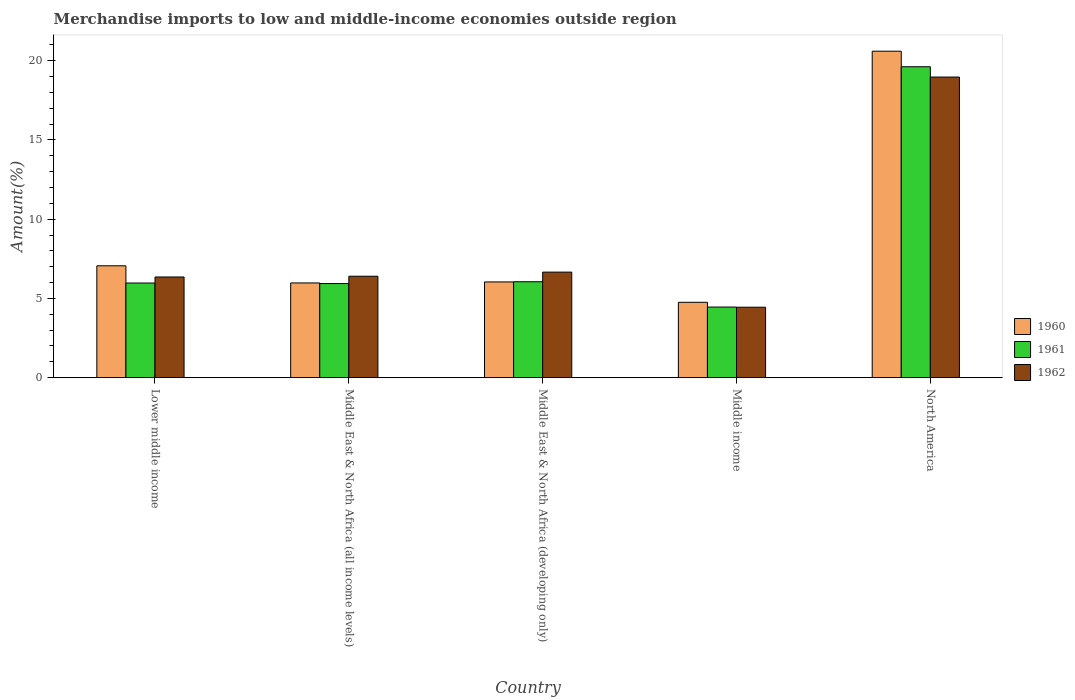How many groups of bars are there?
Your answer should be very brief. 5. Are the number of bars per tick equal to the number of legend labels?
Ensure brevity in your answer.  Yes. Are the number of bars on each tick of the X-axis equal?
Offer a very short reply. Yes. What is the percentage of amount earned from merchandise imports in 1961 in Lower middle income?
Your answer should be compact. 5.97. Across all countries, what is the maximum percentage of amount earned from merchandise imports in 1960?
Offer a terse response. 20.6. Across all countries, what is the minimum percentage of amount earned from merchandise imports in 1962?
Keep it short and to the point. 4.44. In which country was the percentage of amount earned from merchandise imports in 1961 maximum?
Provide a succinct answer. North America. In which country was the percentage of amount earned from merchandise imports in 1961 minimum?
Offer a terse response. Middle income. What is the total percentage of amount earned from merchandise imports in 1960 in the graph?
Give a very brief answer. 44.43. What is the difference between the percentage of amount earned from merchandise imports in 1962 in Middle East & North Africa (all income levels) and that in Middle East & North Africa (developing only)?
Make the answer very short. -0.26. What is the difference between the percentage of amount earned from merchandise imports in 1961 in Middle East & North Africa (all income levels) and the percentage of amount earned from merchandise imports in 1962 in Middle income?
Provide a short and direct response. 1.49. What is the average percentage of amount earned from merchandise imports in 1962 per country?
Your answer should be compact. 8.56. What is the difference between the percentage of amount earned from merchandise imports of/in 1961 and percentage of amount earned from merchandise imports of/in 1962 in Middle East & North Africa (developing only)?
Give a very brief answer. -0.61. What is the ratio of the percentage of amount earned from merchandise imports in 1962 in Middle income to that in North America?
Provide a short and direct response. 0.23. Is the percentage of amount earned from merchandise imports in 1962 in Lower middle income less than that in Middle income?
Ensure brevity in your answer.  No. Is the difference between the percentage of amount earned from merchandise imports in 1961 in Middle East & North Africa (developing only) and Middle income greater than the difference between the percentage of amount earned from merchandise imports in 1962 in Middle East & North Africa (developing only) and Middle income?
Keep it short and to the point. No. What is the difference between the highest and the second highest percentage of amount earned from merchandise imports in 1962?
Provide a short and direct response. 12.31. What is the difference between the highest and the lowest percentage of amount earned from merchandise imports in 1961?
Provide a short and direct response. 15.16. In how many countries, is the percentage of amount earned from merchandise imports in 1962 greater than the average percentage of amount earned from merchandise imports in 1962 taken over all countries?
Offer a very short reply. 1. How many bars are there?
Your answer should be very brief. 15. How many countries are there in the graph?
Provide a succinct answer. 5. Does the graph contain grids?
Ensure brevity in your answer.  No. How many legend labels are there?
Your answer should be very brief. 3. How are the legend labels stacked?
Ensure brevity in your answer.  Vertical. What is the title of the graph?
Offer a terse response. Merchandise imports to low and middle-income economies outside region. Does "2011" appear as one of the legend labels in the graph?
Your response must be concise. No. What is the label or title of the X-axis?
Your answer should be very brief. Country. What is the label or title of the Y-axis?
Keep it short and to the point. Amount(%). What is the Amount(%) in 1960 in Lower middle income?
Provide a short and direct response. 7.06. What is the Amount(%) in 1961 in Lower middle income?
Keep it short and to the point. 5.97. What is the Amount(%) of 1962 in Lower middle income?
Ensure brevity in your answer.  6.35. What is the Amount(%) of 1960 in Middle East & North Africa (all income levels)?
Your response must be concise. 5.98. What is the Amount(%) in 1961 in Middle East & North Africa (all income levels)?
Provide a short and direct response. 5.94. What is the Amount(%) in 1962 in Middle East & North Africa (all income levels)?
Provide a short and direct response. 6.4. What is the Amount(%) of 1960 in Middle East & North Africa (developing only)?
Keep it short and to the point. 6.04. What is the Amount(%) in 1961 in Middle East & North Africa (developing only)?
Your answer should be very brief. 6.05. What is the Amount(%) in 1962 in Middle East & North Africa (developing only)?
Your response must be concise. 6.66. What is the Amount(%) in 1960 in Middle income?
Provide a short and direct response. 4.75. What is the Amount(%) of 1961 in Middle income?
Offer a terse response. 4.45. What is the Amount(%) in 1962 in Middle income?
Provide a short and direct response. 4.44. What is the Amount(%) in 1960 in North America?
Provide a succinct answer. 20.6. What is the Amount(%) in 1961 in North America?
Your answer should be very brief. 19.62. What is the Amount(%) in 1962 in North America?
Provide a short and direct response. 18.97. Across all countries, what is the maximum Amount(%) of 1960?
Keep it short and to the point. 20.6. Across all countries, what is the maximum Amount(%) in 1961?
Your answer should be compact. 19.62. Across all countries, what is the maximum Amount(%) of 1962?
Ensure brevity in your answer.  18.97. Across all countries, what is the minimum Amount(%) of 1960?
Offer a very short reply. 4.75. Across all countries, what is the minimum Amount(%) in 1961?
Your answer should be very brief. 4.45. Across all countries, what is the minimum Amount(%) of 1962?
Provide a short and direct response. 4.44. What is the total Amount(%) in 1960 in the graph?
Provide a short and direct response. 44.43. What is the total Amount(%) in 1961 in the graph?
Give a very brief answer. 42.03. What is the total Amount(%) of 1962 in the graph?
Provide a succinct answer. 42.82. What is the difference between the Amount(%) in 1960 in Lower middle income and that in Middle East & North Africa (all income levels)?
Your answer should be compact. 1.08. What is the difference between the Amount(%) of 1961 in Lower middle income and that in Middle East & North Africa (all income levels)?
Ensure brevity in your answer.  0.03. What is the difference between the Amount(%) of 1962 in Lower middle income and that in Middle East & North Africa (all income levels)?
Give a very brief answer. -0.05. What is the difference between the Amount(%) of 1960 in Lower middle income and that in Middle East & North Africa (developing only)?
Your answer should be compact. 1.02. What is the difference between the Amount(%) in 1961 in Lower middle income and that in Middle East & North Africa (developing only)?
Provide a succinct answer. -0.08. What is the difference between the Amount(%) of 1962 in Lower middle income and that in Middle East & North Africa (developing only)?
Your answer should be compact. -0.31. What is the difference between the Amount(%) in 1960 in Lower middle income and that in Middle income?
Your response must be concise. 2.3. What is the difference between the Amount(%) of 1961 in Lower middle income and that in Middle income?
Offer a very short reply. 1.52. What is the difference between the Amount(%) in 1962 in Lower middle income and that in Middle income?
Ensure brevity in your answer.  1.91. What is the difference between the Amount(%) of 1960 in Lower middle income and that in North America?
Keep it short and to the point. -13.54. What is the difference between the Amount(%) of 1961 in Lower middle income and that in North America?
Keep it short and to the point. -13.64. What is the difference between the Amount(%) of 1962 in Lower middle income and that in North America?
Your answer should be compact. -12.61. What is the difference between the Amount(%) in 1960 in Middle East & North Africa (all income levels) and that in Middle East & North Africa (developing only)?
Your response must be concise. -0.06. What is the difference between the Amount(%) in 1961 in Middle East & North Africa (all income levels) and that in Middle East & North Africa (developing only)?
Offer a terse response. -0.11. What is the difference between the Amount(%) in 1962 in Middle East & North Africa (all income levels) and that in Middle East & North Africa (developing only)?
Offer a very short reply. -0.26. What is the difference between the Amount(%) in 1960 in Middle East & North Africa (all income levels) and that in Middle income?
Keep it short and to the point. 1.22. What is the difference between the Amount(%) of 1961 in Middle East & North Africa (all income levels) and that in Middle income?
Provide a succinct answer. 1.48. What is the difference between the Amount(%) of 1962 in Middle East & North Africa (all income levels) and that in Middle income?
Ensure brevity in your answer.  1.95. What is the difference between the Amount(%) in 1960 in Middle East & North Africa (all income levels) and that in North America?
Make the answer very short. -14.62. What is the difference between the Amount(%) in 1961 in Middle East & North Africa (all income levels) and that in North America?
Offer a very short reply. -13.68. What is the difference between the Amount(%) in 1962 in Middle East & North Africa (all income levels) and that in North America?
Your response must be concise. -12.57. What is the difference between the Amount(%) of 1960 in Middle East & North Africa (developing only) and that in Middle income?
Offer a very short reply. 1.29. What is the difference between the Amount(%) of 1961 in Middle East & North Africa (developing only) and that in Middle income?
Make the answer very short. 1.6. What is the difference between the Amount(%) of 1962 in Middle East & North Africa (developing only) and that in Middle income?
Provide a short and direct response. 2.21. What is the difference between the Amount(%) of 1960 in Middle East & North Africa (developing only) and that in North America?
Make the answer very short. -14.56. What is the difference between the Amount(%) of 1961 in Middle East & North Africa (developing only) and that in North America?
Your answer should be very brief. -13.56. What is the difference between the Amount(%) of 1962 in Middle East & North Africa (developing only) and that in North America?
Ensure brevity in your answer.  -12.31. What is the difference between the Amount(%) of 1960 in Middle income and that in North America?
Your answer should be compact. -15.84. What is the difference between the Amount(%) of 1961 in Middle income and that in North America?
Your answer should be very brief. -15.16. What is the difference between the Amount(%) in 1962 in Middle income and that in North America?
Your response must be concise. -14.52. What is the difference between the Amount(%) in 1960 in Lower middle income and the Amount(%) in 1961 in Middle East & North Africa (all income levels)?
Ensure brevity in your answer.  1.12. What is the difference between the Amount(%) of 1960 in Lower middle income and the Amount(%) of 1962 in Middle East & North Africa (all income levels)?
Make the answer very short. 0.66. What is the difference between the Amount(%) of 1961 in Lower middle income and the Amount(%) of 1962 in Middle East & North Africa (all income levels)?
Your answer should be compact. -0.43. What is the difference between the Amount(%) of 1960 in Lower middle income and the Amount(%) of 1961 in Middle East & North Africa (developing only)?
Offer a very short reply. 1.01. What is the difference between the Amount(%) in 1960 in Lower middle income and the Amount(%) in 1962 in Middle East & North Africa (developing only)?
Your response must be concise. 0.4. What is the difference between the Amount(%) in 1961 in Lower middle income and the Amount(%) in 1962 in Middle East & North Africa (developing only)?
Make the answer very short. -0.69. What is the difference between the Amount(%) in 1960 in Lower middle income and the Amount(%) in 1961 in Middle income?
Your response must be concise. 2.6. What is the difference between the Amount(%) in 1960 in Lower middle income and the Amount(%) in 1962 in Middle income?
Give a very brief answer. 2.61. What is the difference between the Amount(%) in 1961 in Lower middle income and the Amount(%) in 1962 in Middle income?
Offer a very short reply. 1.53. What is the difference between the Amount(%) of 1960 in Lower middle income and the Amount(%) of 1961 in North America?
Offer a very short reply. -12.56. What is the difference between the Amount(%) of 1960 in Lower middle income and the Amount(%) of 1962 in North America?
Keep it short and to the point. -11.91. What is the difference between the Amount(%) of 1961 in Lower middle income and the Amount(%) of 1962 in North America?
Your response must be concise. -12.99. What is the difference between the Amount(%) of 1960 in Middle East & North Africa (all income levels) and the Amount(%) of 1961 in Middle East & North Africa (developing only)?
Provide a short and direct response. -0.08. What is the difference between the Amount(%) in 1960 in Middle East & North Africa (all income levels) and the Amount(%) in 1962 in Middle East & North Africa (developing only)?
Provide a succinct answer. -0.68. What is the difference between the Amount(%) of 1961 in Middle East & North Africa (all income levels) and the Amount(%) of 1962 in Middle East & North Africa (developing only)?
Keep it short and to the point. -0.72. What is the difference between the Amount(%) of 1960 in Middle East & North Africa (all income levels) and the Amount(%) of 1961 in Middle income?
Provide a succinct answer. 1.52. What is the difference between the Amount(%) of 1960 in Middle East & North Africa (all income levels) and the Amount(%) of 1962 in Middle income?
Your answer should be compact. 1.53. What is the difference between the Amount(%) of 1961 in Middle East & North Africa (all income levels) and the Amount(%) of 1962 in Middle income?
Make the answer very short. 1.49. What is the difference between the Amount(%) of 1960 in Middle East & North Africa (all income levels) and the Amount(%) of 1961 in North America?
Your answer should be very brief. -13.64. What is the difference between the Amount(%) in 1960 in Middle East & North Africa (all income levels) and the Amount(%) in 1962 in North America?
Your answer should be very brief. -12.99. What is the difference between the Amount(%) in 1961 in Middle East & North Africa (all income levels) and the Amount(%) in 1962 in North America?
Offer a very short reply. -13.03. What is the difference between the Amount(%) of 1960 in Middle East & North Africa (developing only) and the Amount(%) of 1961 in Middle income?
Offer a very short reply. 1.59. What is the difference between the Amount(%) of 1960 in Middle East & North Africa (developing only) and the Amount(%) of 1962 in Middle income?
Ensure brevity in your answer.  1.6. What is the difference between the Amount(%) of 1961 in Middle East & North Africa (developing only) and the Amount(%) of 1962 in Middle income?
Give a very brief answer. 1.61. What is the difference between the Amount(%) in 1960 in Middle East & North Africa (developing only) and the Amount(%) in 1961 in North America?
Your answer should be very brief. -13.58. What is the difference between the Amount(%) of 1960 in Middle East & North Africa (developing only) and the Amount(%) of 1962 in North America?
Give a very brief answer. -12.93. What is the difference between the Amount(%) in 1961 in Middle East & North Africa (developing only) and the Amount(%) in 1962 in North America?
Provide a succinct answer. -12.91. What is the difference between the Amount(%) in 1960 in Middle income and the Amount(%) in 1961 in North America?
Keep it short and to the point. -14.86. What is the difference between the Amount(%) in 1960 in Middle income and the Amount(%) in 1962 in North America?
Your answer should be compact. -14.21. What is the difference between the Amount(%) in 1961 in Middle income and the Amount(%) in 1962 in North America?
Provide a short and direct response. -14.51. What is the average Amount(%) in 1960 per country?
Provide a short and direct response. 8.89. What is the average Amount(%) of 1961 per country?
Offer a terse response. 8.41. What is the average Amount(%) in 1962 per country?
Provide a short and direct response. 8.56. What is the difference between the Amount(%) of 1960 and Amount(%) of 1961 in Lower middle income?
Ensure brevity in your answer.  1.09. What is the difference between the Amount(%) in 1960 and Amount(%) in 1962 in Lower middle income?
Offer a very short reply. 0.71. What is the difference between the Amount(%) of 1961 and Amount(%) of 1962 in Lower middle income?
Your response must be concise. -0.38. What is the difference between the Amount(%) of 1960 and Amount(%) of 1961 in Middle East & North Africa (all income levels)?
Offer a terse response. 0.04. What is the difference between the Amount(%) in 1960 and Amount(%) in 1962 in Middle East & North Africa (all income levels)?
Provide a short and direct response. -0.42. What is the difference between the Amount(%) of 1961 and Amount(%) of 1962 in Middle East & North Africa (all income levels)?
Offer a very short reply. -0.46. What is the difference between the Amount(%) of 1960 and Amount(%) of 1961 in Middle East & North Africa (developing only)?
Your answer should be compact. -0.01. What is the difference between the Amount(%) in 1960 and Amount(%) in 1962 in Middle East & North Africa (developing only)?
Your answer should be compact. -0.62. What is the difference between the Amount(%) in 1961 and Amount(%) in 1962 in Middle East & North Africa (developing only)?
Provide a short and direct response. -0.61. What is the difference between the Amount(%) in 1960 and Amount(%) in 1961 in Middle income?
Your answer should be very brief. 0.3. What is the difference between the Amount(%) of 1960 and Amount(%) of 1962 in Middle income?
Ensure brevity in your answer.  0.31. What is the difference between the Amount(%) in 1961 and Amount(%) in 1962 in Middle income?
Keep it short and to the point. 0.01. What is the difference between the Amount(%) in 1960 and Amount(%) in 1961 in North America?
Your answer should be compact. 0.98. What is the difference between the Amount(%) of 1960 and Amount(%) of 1962 in North America?
Provide a short and direct response. 1.63. What is the difference between the Amount(%) of 1961 and Amount(%) of 1962 in North America?
Your response must be concise. 0.65. What is the ratio of the Amount(%) of 1960 in Lower middle income to that in Middle East & North Africa (all income levels)?
Your answer should be very brief. 1.18. What is the ratio of the Amount(%) in 1961 in Lower middle income to that in Middle East & North Africa (all income levels)?
Keep it short and to the point. 1.01. What is the ratio of the Amount(%) of 1960 in Lower middle income to that in Middle East & North Africa (developing only)?
Provide a short and direct response. 1.17. What is the ratio of the Amount(%) in 1961 in Lower middle income to that in Middle East & North Africa (developing only)?
Provide a short and direct response. 0.99. What is the ratio of the Amount(%) of 1962 in Lower middle income to that in Middle East & North Africa (developing only)?
Keep it short and to the point. 0.95. What is the ratio of the Amount(%) of 1960 in Lower middle income to that in Middle income?
Your answer should be very brief. 1.48. What is the ratio of the Amount(%) in 1961 in Lower middle income to that in Middle income?
Offer a terse response. 1.34. What is the ratio of the Amount(%) of 1962 in Lower middle income to that in Middle income?
Make the answer very short. 1.43. What is the ratio of the Amount(%) of 1960 in Lower middle income to that in North America?
Offer a very short reply. 0.34. What is the ratio of the Amount(%) of 1961 in Lower middle income to that in North America?
Offer a very short reply. 0.3. What is the ratio of the Amount(%) in 1962 in Lower middle income to that in North America?
Keep it short and to the point. 0.33. What is the ratio of the Amount(%) of 1960 in Middle East & North Africa (all income levels) to that in Middle East & North Africa (developing only)?
Keep it short and to the point. 0.99. What is the ratio of the Amount(%) of 1961 in Middle East & North Africa (all income levels) to that in Middle East & North Africa (developing only)?
Ensure brevity in your answer.  0.98. What is the ratio of the Amount(%) of 1962 in Middle East & North Africa (all income levels) to that in Middle East & North Africa (developing only)?
Provide a succinct answer. 0.96. What is the ratio of the Amount(%) of 1960 in Middle East & North Africa (all income levels) to that in Middle income?
Ensure brevity in your answer.  1.26. What is the ratio of the Amount(%) in 1961 in Middle East & North Africa (all income levels) to that in Middle income?
Offer a terse response. 1.33. What is the ratio of the Amount(%) of 1962 in Middle East & North Africa (all income levels) to that in Middle income?
Provide a short and direct response. 1.44. What is the ratio of the Amount(%) in 1960 in Middle East & North Africa (all income levels) to that in North America?
Your answer should be compact. 0.29. What is the ratio of the Amount(%) in 1961 in Middle East & North Africa (all income levels) to that in North America?
Offer a terse response. 0.3. What is the ratio of the Amount(%) in 1962 in Middle East & North Africa (all income levels) to that in North America?
Your response must be concise. 0.34. What is the ratio of the Amount(%) in 1960 in Middle East & North Africa (developing only) to that in Middle income?
Your answer should be compact. 1.27. What is the ratio of the Amount(%) of 1961 in Middle East & North Africa (developing only) to that in Middle income?
Provide a succinct answer. 1.36. What is the ratio of the Amount(%) in 1962 in Middle East & North Africa (developing only) to that in Middle income?
Your answer should be compact. 1.5. What is the ratio of the Amount(%) in 1960 in Middle East & North Africa (developing only) to that in North America?
Your answer should be compact. 0.29. What is the ratio of the Amount(%) in 1961 in Middle East & North Africa (developing only) to that in North America?
Keep it short and to the point. 0.31. What is the ratio of the Amount(%) of 1962 in Middle East & North Africa (developing only) to that in North America?
Offer a terse response. 0.35. What is the ratio of the Amount(%) of 1960 in Middle income to that in North America?
Make the answer very short. 0.23. What is the ratio of the Amount(%) of 1961 in Middle income to that in North America?
Your response must be concise. 0.23. What is the ratio of the Amount(%) in 1962 in Middle income to that in North America?
Ensure brevity in your answer.  0.23. What is the difference between the highest and the second highest Amount(%) of 1960?
Offer a very short reply. 13.54. What is the difference between the highest and the second highest Amount(%) in 1961?
Provide a short and direct response. 13.56. What is the difference between the highest and the second highest Amount(%) in 1962?
Your response must be concise. 12.31. What is the difference between the highest and the lowest Amount(%) of 1960?
Your response must be concise. 15.84. What is the difference between the highest and the lowest Amount(%) in 1961?
Offer a terse response. 15.16. What is the difference between the highest and the lowest Amount(%) in 1962?
Your answer should be very brief. 14.52. 